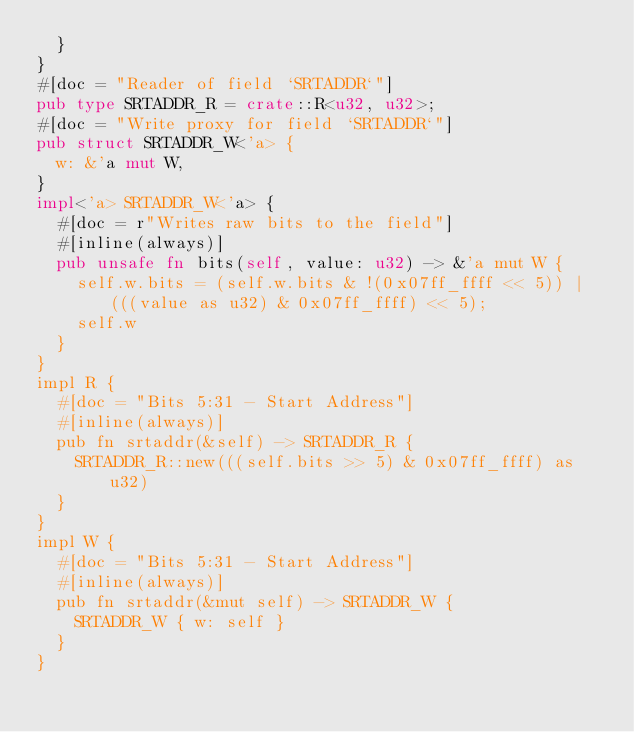Convert code to text. <code><loc_0><loc_0><loc_500><loc_500><_Rust_>  }
}
#[doc = "Reader of field `SRTADDR`"]
pub type SRTADDR_R = crate::R<u32, u32>;
#[doc = "Write proxy for field `SRTADDR`"]
pub struct SRTADDR_W<'a> {
  w: &'a mut W,
}
impl<'a> SRTADDR_W<'a> {
  #[doc = r"Writes raw bits to the field"]
  #[inline(always)]
  pub unsafe fn bits(self, value: u32) -> &'a mut W {
    self.w.bits = (self.w.bits & !(0x07ff_ffff << 5)) | (((value as u32) & 0x07ff_ffff) << 5);
    self.w
  }
}
impl R {
  #[doc = "Bits 5:31 - Start Address"]
  #[inline(always)]
  pub fn srtaddr(&self) -> SRTADDR_R {
    SRTADDR_R::new(((self.bits >> 5) & 0x07ff_ffff) as u32)
  }
}
impl W {
  #[doc = "Bits 5:31 - Start Address"]
  #[inline(always)]
  pub fn srtaddr(&mut self) -> SRTADDR_W {
    SRTADDR_W { w: self }
  }
}
</code> 